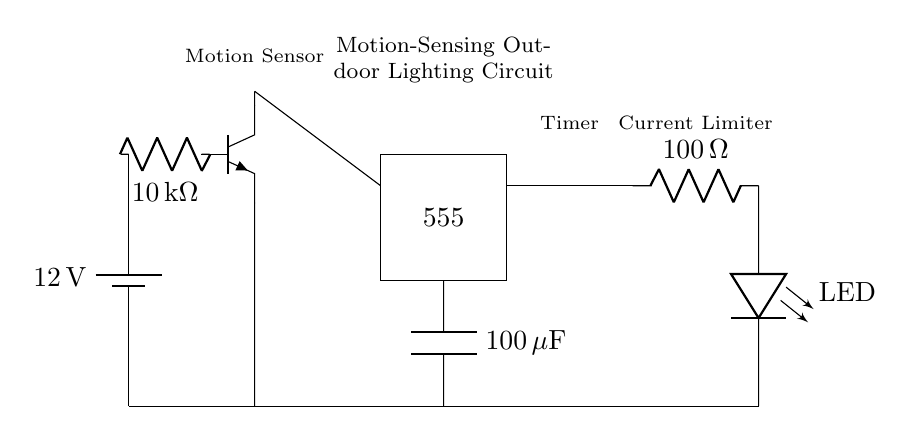What is the battery voltage in this circuit? The battery provides a voltage supply and is labeled as 12 volts in the diagram.
Answer: 12 volts What is the function of the 100 ohm resistor? The 100 ohm resistor is placed in series to limit the current flowing to the LED, preventing it from burning out due to excessive current.
Answer: Current limiter What component is used for motion sensing? The diagram indicates a component labeled as "Motion Sensor" which is shown with an npn transistor symbol, serving the role of detecting motion.
Answer: Motion Sensor What type of timer is used in this circuit? The circuit depicts a 555 timer IC, illustrated as a rectangle with the number 555 inside it, indicating it is a timer component.
Answer: 555 timer How does the circuit respond when motion is detected? When motion is detected by the motion sensor, it activates the 555 timer, allowing current to flow through the LED circuit and light it up for a set duration as determined by the timer settings.
Answer: Lights up Which component ensures the LED does not receive too much current? The component responsible for this is the 100 ohm resistor, which restricts current flow to the LED and protects it from damage.
Answer: 100 ohm resistor 